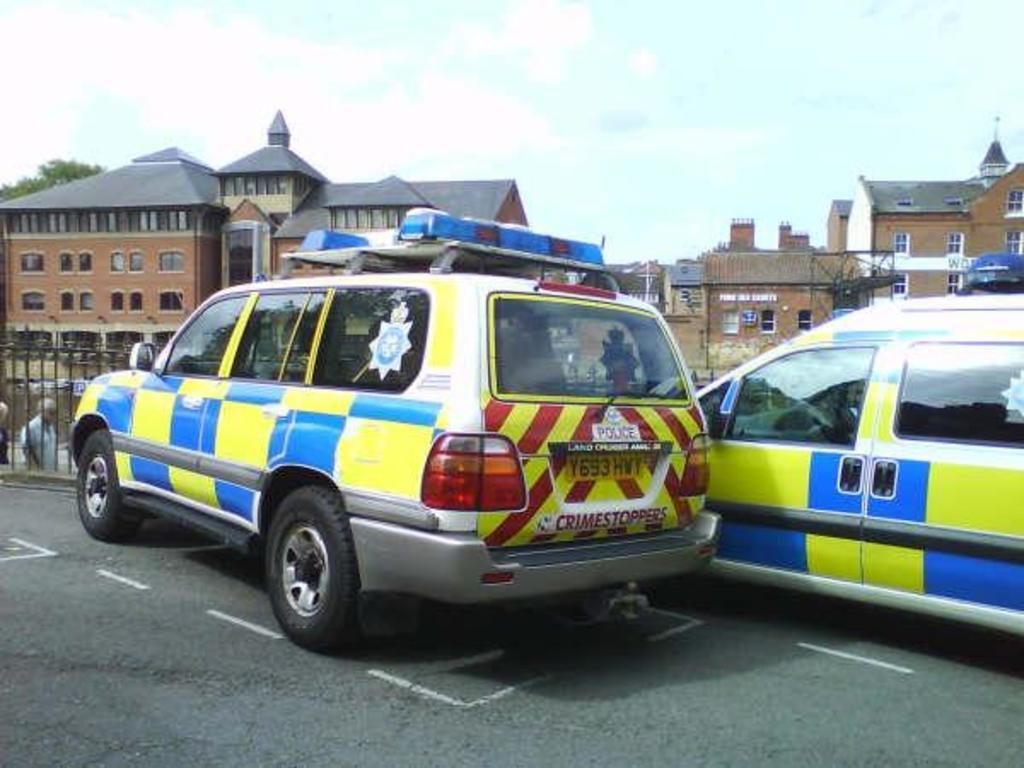Describe this image in one or two sentences. This image is clicked on the road. There are cars parked on the road. Behind the cars there is a railing. In the background there are buildings. Behind the buildings there are trees. At the top there is the sky. To the left there are people walking. 